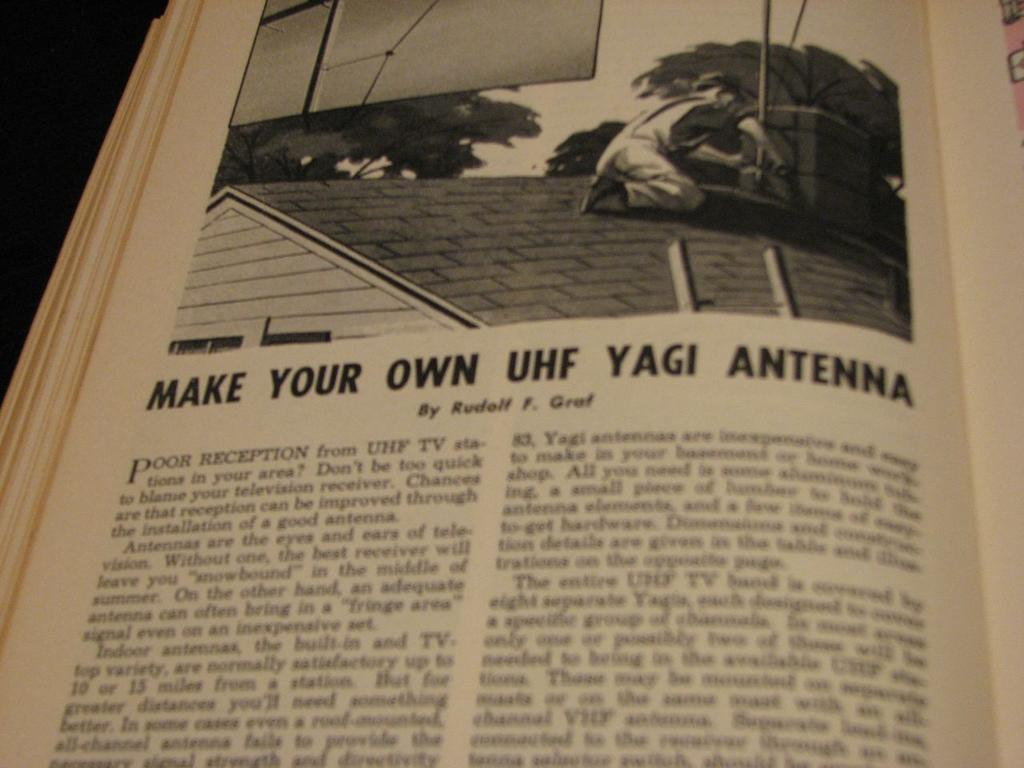<image>
Share a concise interpretation of the image provided. A page from a book detaling how to make your own UHF Yagi antenna. 